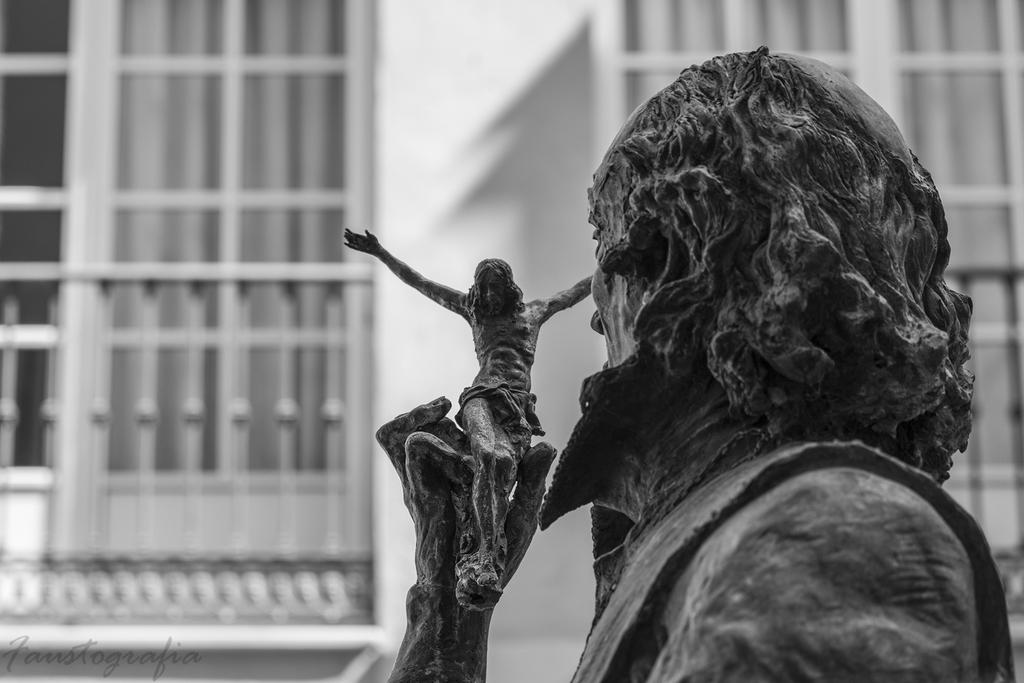What is the main subject of the image? There is a statue of a man in the image. What is the man holding in his hands? The man is holding a Jesus sculpture in his hands. Can you describe the Jesus sculpture? The Jesus sculpture is black in color. What can be seen in the background of the image? There is a wall and windows in the background of the image. What type of dress is the moon wearing in the image? There is no moon or dress present in the image. What is the frame made of that surrounds the statue? There is no frame mentioned or visible in the image. 